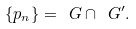<formula> <loc_0><loc_0><loc_500><loc_500>\{ p _ { n } \} = \ G \cap \ G ^ { \prime } .</formula> 